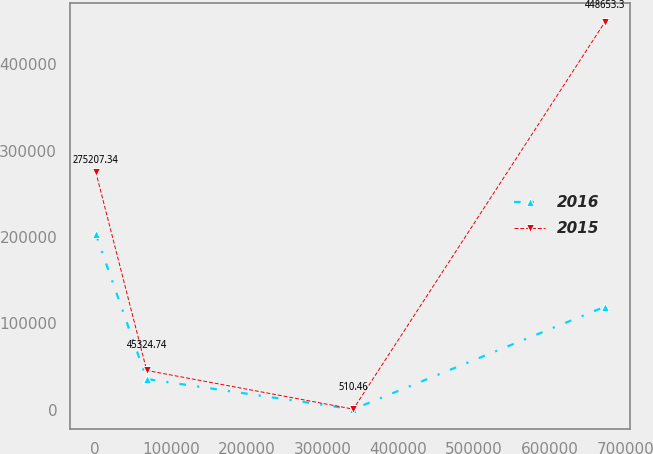<chart> <loc_0><loc_0><loc_500><loc_500><line_chart><ecel><fcel>2016<fcel>2015<nl><fcel>697.89<fcel>203125<fcel>275207<nl><fcel>67898.6<fcel>35339.2<fcel>45324.7<nl><fcel>340626<fcel>402.22<fcel>510.46<nl><fcel>672705<fcel>119036<fcel>448653<nl></chart> 